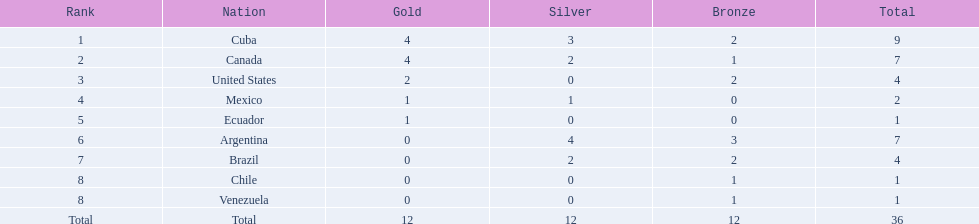Which countries have won gold medals? Cuba, Canada, United States, Mexico, Ecuador. Of these countries, which ones have never won silver or bronze medals? United States, Ecuador. Of the two nations listed previously, which one has only won a gold medal? Ecuador. 